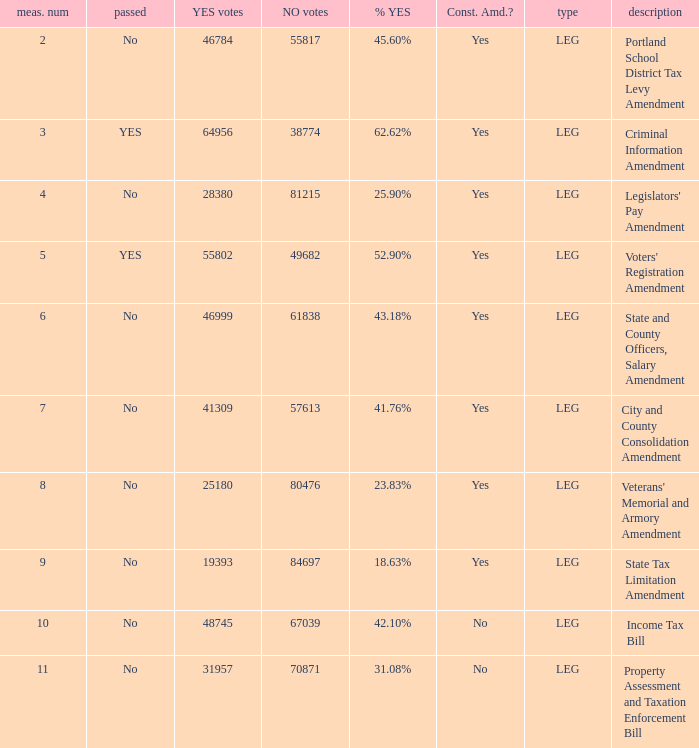How many yes votes made up 43.18% yes? 46999.0. 